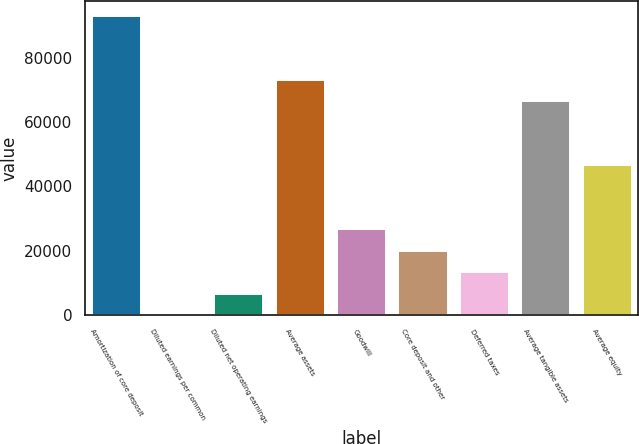<chart> <loc_0><loc_0><loc_500><loc_500><bar_chart><fcel>Amortization of core deposit<fcel>Diluted earnings per common<fcel>Diluted net operating earnings<fcel>Average assets<fcel>Goodwill<fcel>Core deposit and other<fcel>Deferred taxes<fcel>Average tangible assets<fcel>Average equity<nl><fcel>93078<fcel>5.95<fcel>6653.96<fcel>73134<fcel>26598<fcel>19950<fcel>13302<fcel>66486<fcel>46542<nl></chart> 